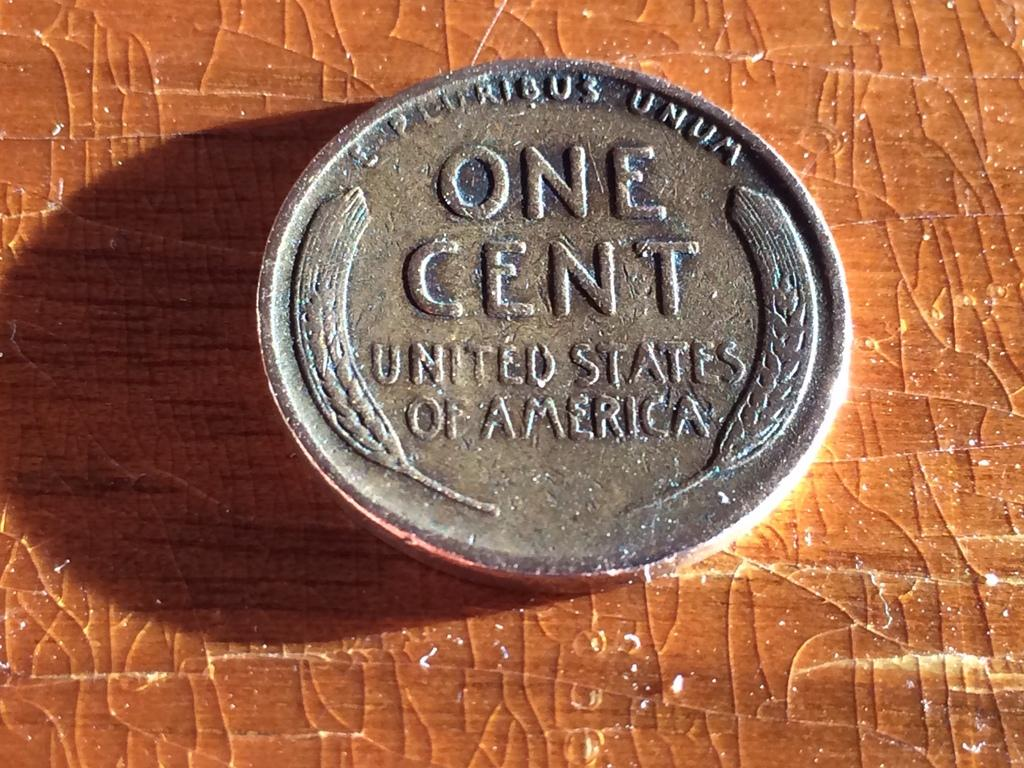<image>
Relay a brief, clear account of the picture shown. an old one cent united states of america coin on a chipped surface 